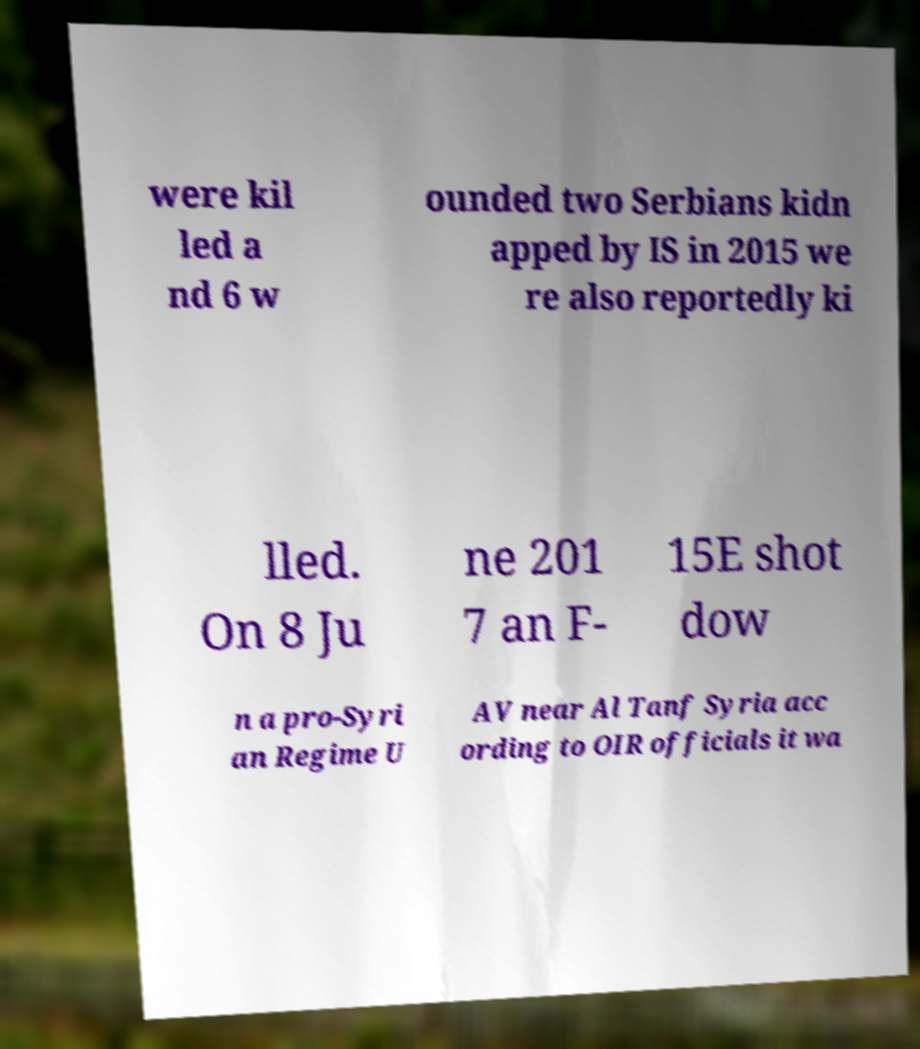Could you assist in decoding the text presented in this image and type it out clearly? were kil led a nd 6 w ounded two Serbians kidn apped by IS in 2015 we re also reportedly ki lled. On 8 Ju ne 201 7 an F- 15E shot dow n a pro-Syri an Regime U AV near Al Tanf Syria acc ording to OIR officials it wa 